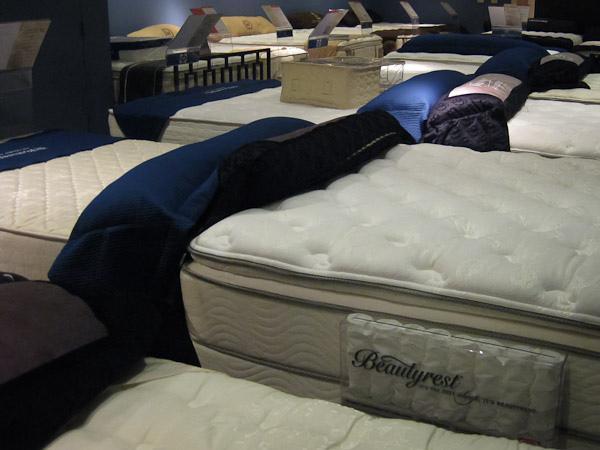How many beds are there?
Give a very brief answer. 8. 